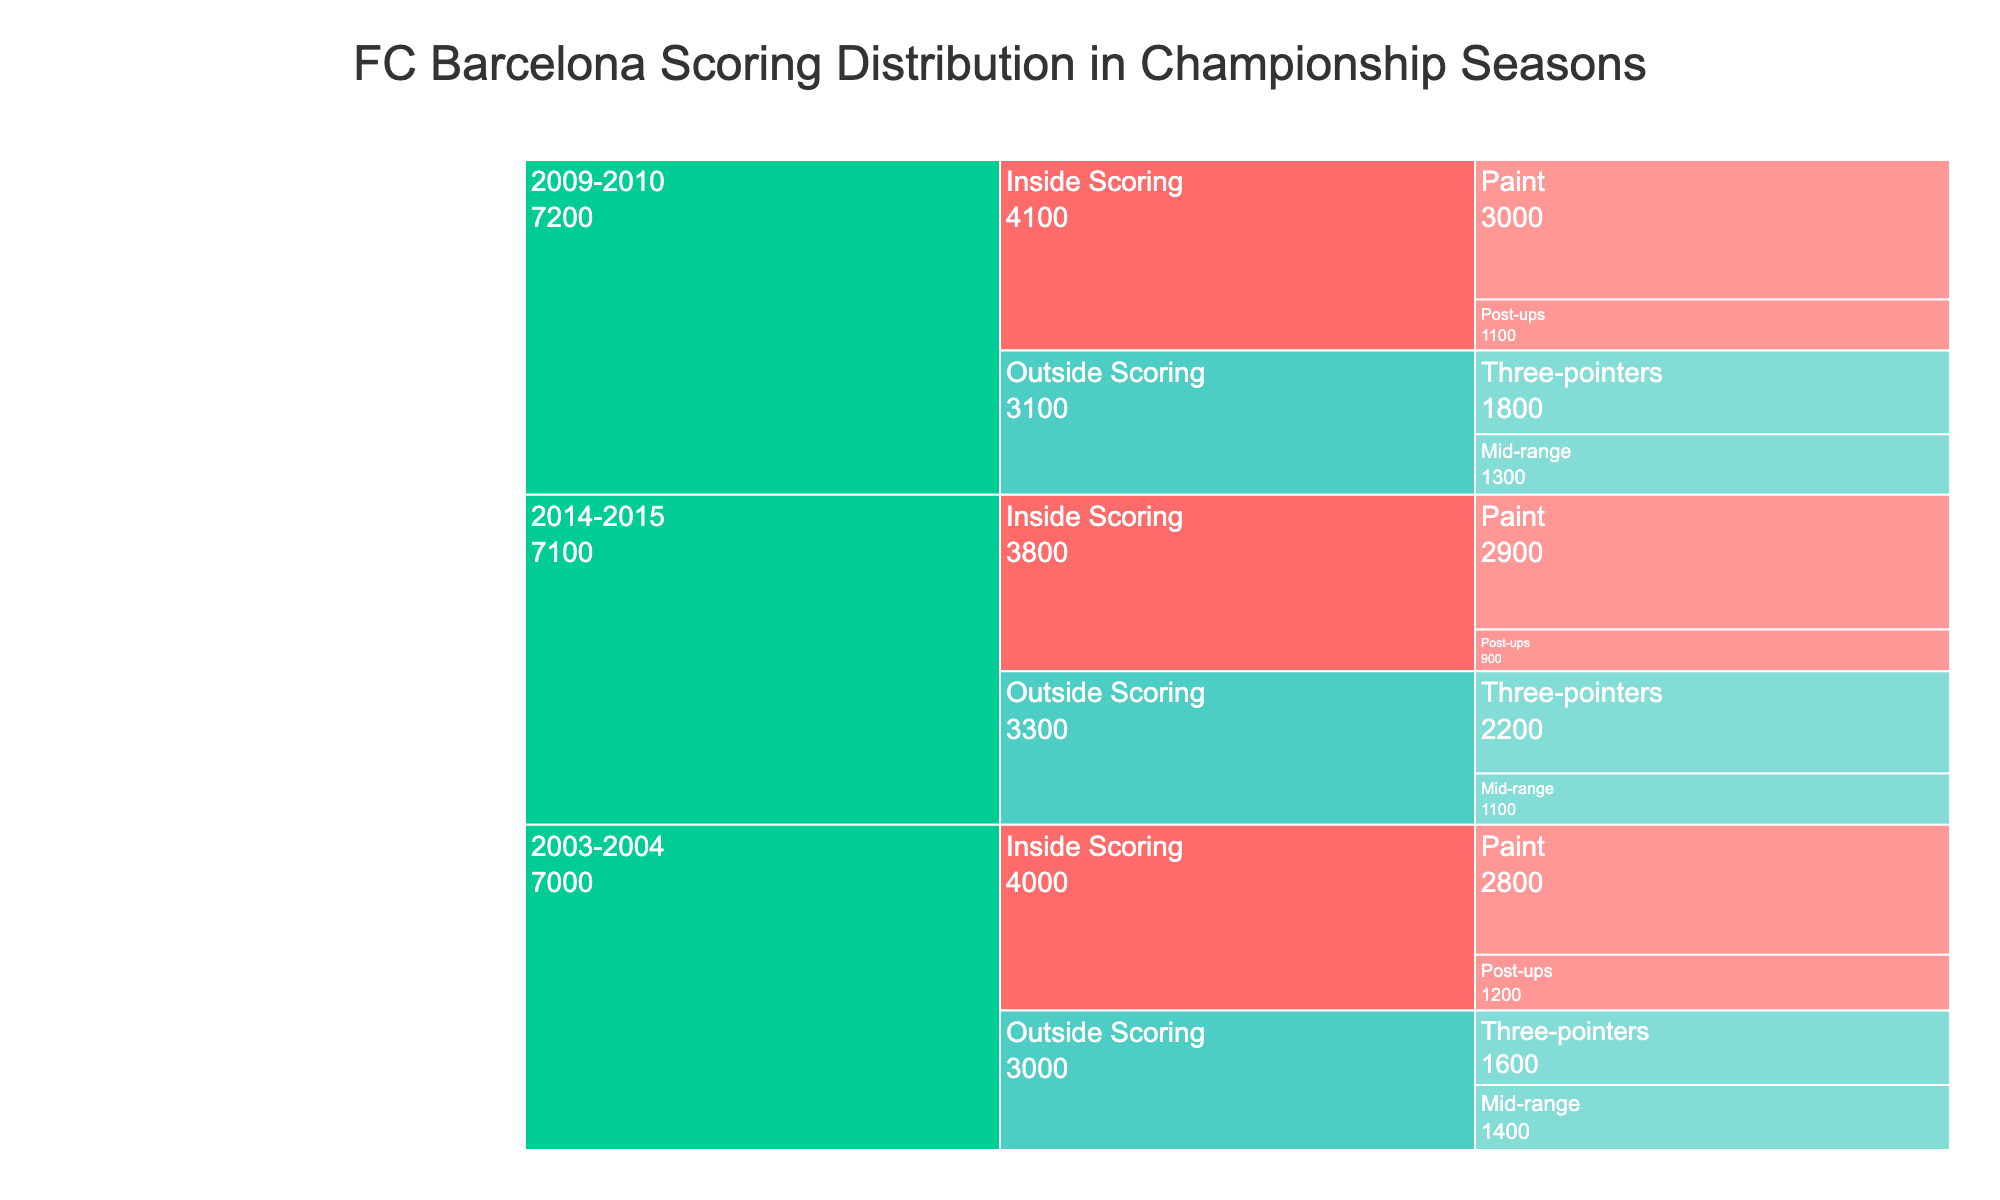what are the scoring categories shown in the icicle chart? The icicle chart breaks down the scoring distribution into two main categories: Inside Scoring and Outside Scoring. You can observe these categories by looking at the branching structure of the chart.
Answer: Inside Scoring, Outside Scoring Which season had the highest points from three-pointers? To determine this, look at the points under the "Outside Scoring" category for the "Three-pointers" subcategory. Compare the values for each season: 2003-2004 (1600), 2009-2010 (1800), and 2014-2015 (2200).
Answer: 2014-2015 What is the total points for Inside Scoring in the 2003-2004 season? Inside Scoring in the 2003-2004 season includes Paint (2800) and Post-ups (1200). Summing these values gives 2800 + 1200 = 4000.
Answer: 4000 How do the points for Post-ups compare between the 2009-2010 and 2014-2015 seasons? Look at the points for "Post-ups" under "Inside Scoring" for the two seasons. The points are 1100 for 2009-2010 and 900 for 2014-2015. 1100 is greater than 900.
Answer: 2009-2010 had more points Which season had the least points for Mid-range scoring? Compare the points for the "Mid-range" subcategory under "Outside Scoring" for each season: 2003-2004 (1400), 2009-2010 (1300), and 2014-2015 (1100). The lowest value is in 2014-2015.
Answer: 2014-2015 What is the difference in total points between Inside Scoring and Outside Scoring in the 2009-2010 season? Inside Scoring in 2009-2010 includes Paint (3000) and Post-ups (1100) which sum to 3000 + 1100 = 4100. Outside Scoring includes Three-pointers (1800) and Mid-range (1300) which sum to 1800 + 1300 = 3100. The difference is 4100 - 3100 = 1000.
Answer: 1000 Which subcategory had the highest points in the 2014-2015 season? Look at the points for each subcategory under the 2014-2015 season: Paint (2900), Post-ups (900), Three-pointers (2200), Mid-range (1100). The highest value is Paint with 2900 points.
Answer: Paint How many total points did FC Barcelona score from Three-pointers across all three seasons combined? Sum the points for the "Three-pointers" subcategory across all seasons: 2003-2004 (1600), 2009-2010 (1800), and 2014-2015 (2200). The total is 1600 + 1800 + 2200 = 5600.
Answer: 5600 In which season did FC Barcelona score more from the Paint than from Three-pointers? Compare the Paint and Three-pointer points for each season: 2003-2004 (Paint: 2800, Three-pointers: 1600), 2009-2010 (Paint: 3000, Three-pointers: 1800), 2014-2015 (Paint: 2900, Three-pointers: 2200). 2003-2004 and 2009-2010 had more points from Paint than from Three-pointers.
Answer: 2003-2004, 2009-2010 